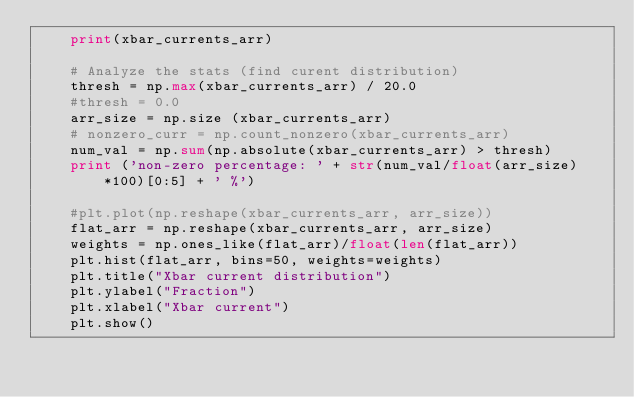Convert code to text. <code><loc_0><loc_0><loc_500><loc_500><_Python_>    print(xbar_currents_arr)

    # Analyze the stats (find curent distribution)
    thresh = np.max(xbar_currents_arr) / 20.0
    #thresh = 0.0
    arr_size = np.size (xbar_currents_arr)
    # nonzero_curr = np.count_nonzero(xbar_currents_arr)
    num_val = np.sum(np.absolute(xbar_currents_arr) > thresh)
    print ('non-zero percentage: ' + str(num_val/float(arr_size)*100)[0:5] + ' %')

    #plt.plot(np.reshape(xbar_currents_arr, arr_size))
    flat_arr = np.reshape(xbar_currents_arr, arr_size)
    weights = np.ones_like(flat_arr)/float(len(flat_arr))
    plt.hist(flat_arr, bins=50, weights=weights)
    plt.title("Xbar current distribution")
    plt.ylabel("Fraction")
    plt.xlabel("Xbar current")
    plt.show()


</code> 